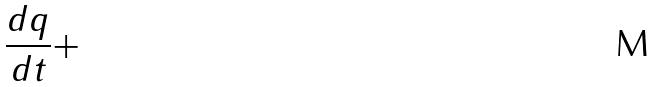Convert formula to latex. <formula><loc_0><loc_0><loc_500><loc_500>\frac { d q } { d t } +</formula> 